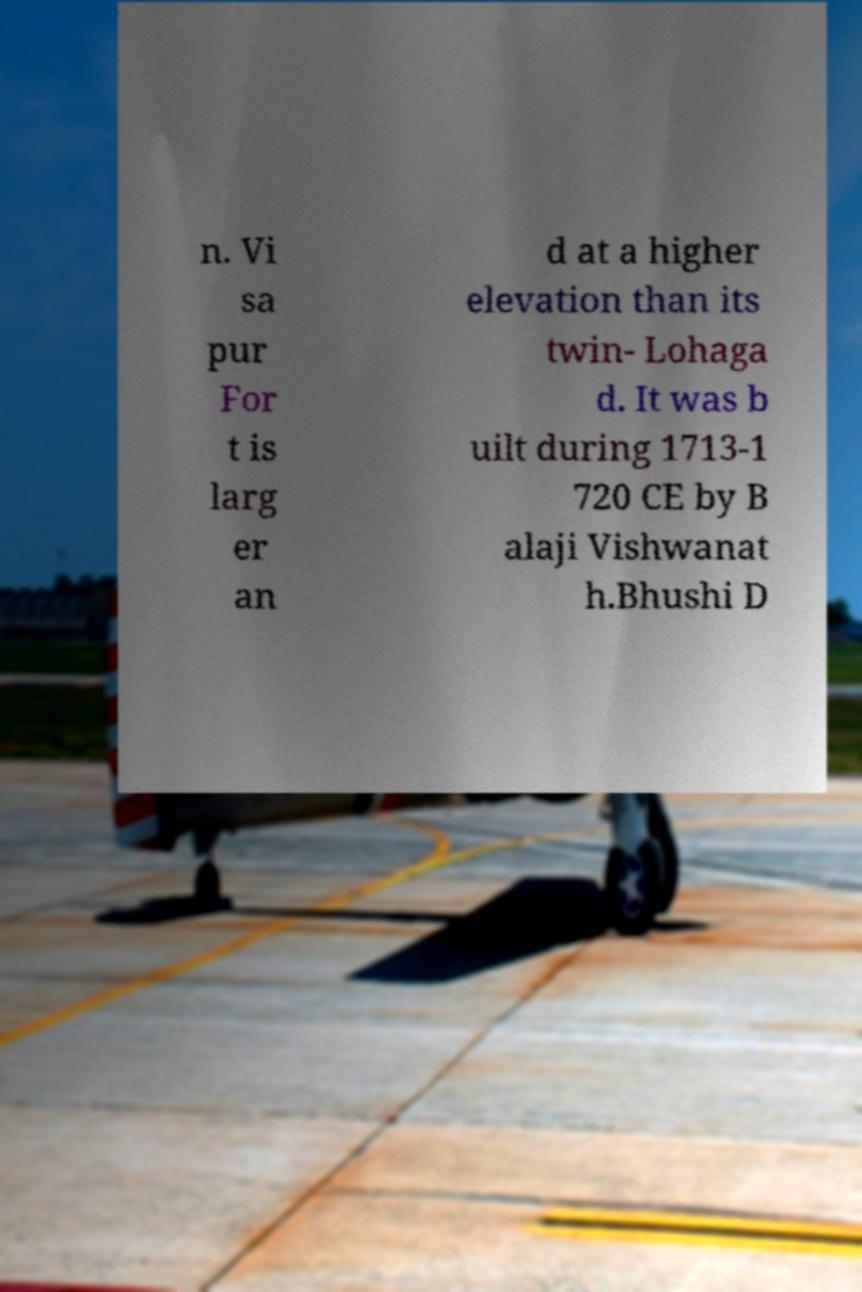Could you assist in decoding the text presented in this image and type it out clearly? n. Vi sa pur For t is larg er an d at a higher elevation than its twin- Lohaga d. It was b uilt during 1713-1 720 CE by B alaji Vishwanat h.Bhushi D 